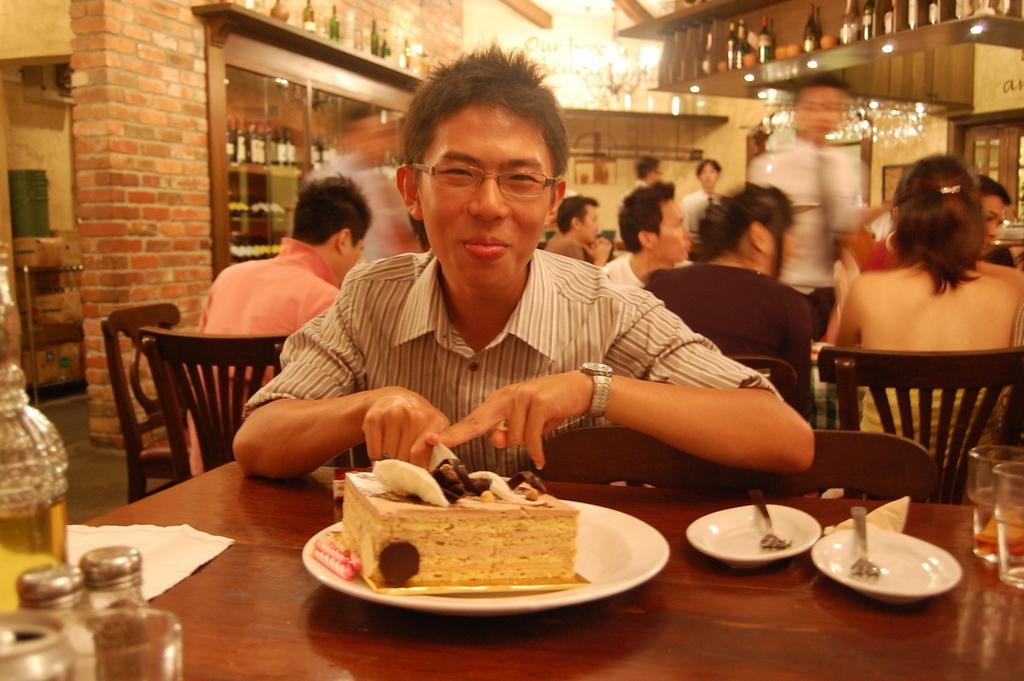Please provide a concise description of this image. In the image there is a man sat on chair in front of table, there is a cake on plate and back side there are many people and it seems to be a restaurant. 